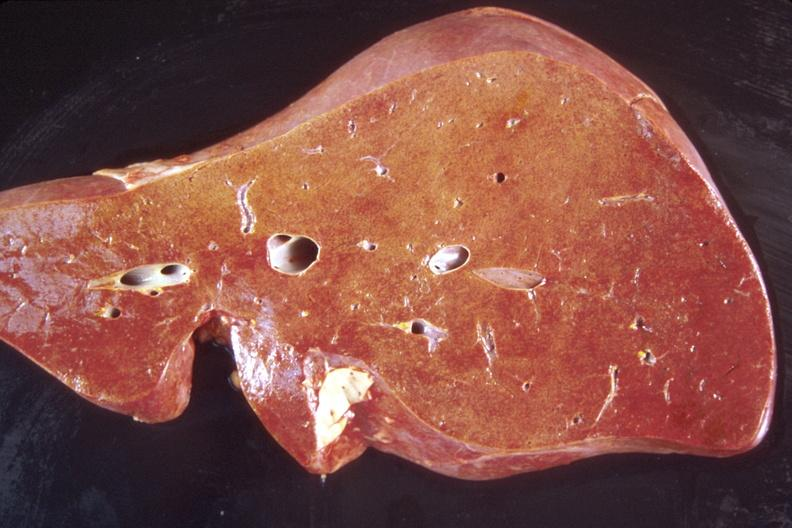what is present?
Answer the question using a single word or phrase. Hepatobiliary 